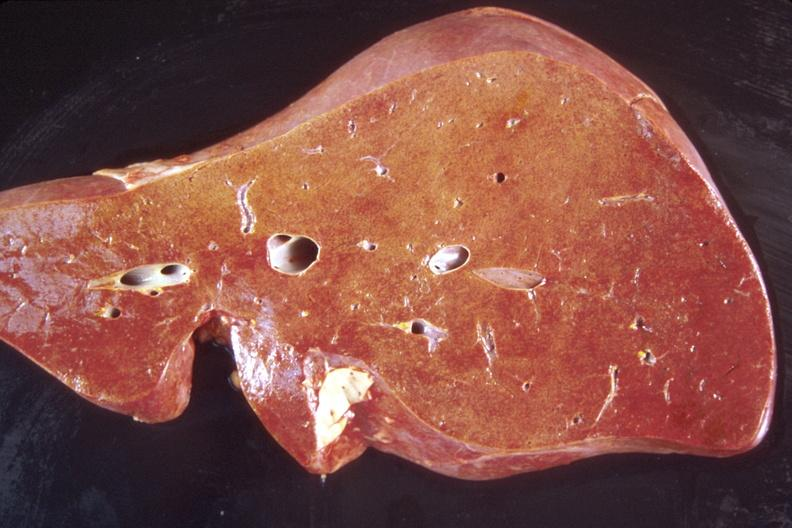what is present?
Answer the question using a single word or phrase. Hepatobiliary 